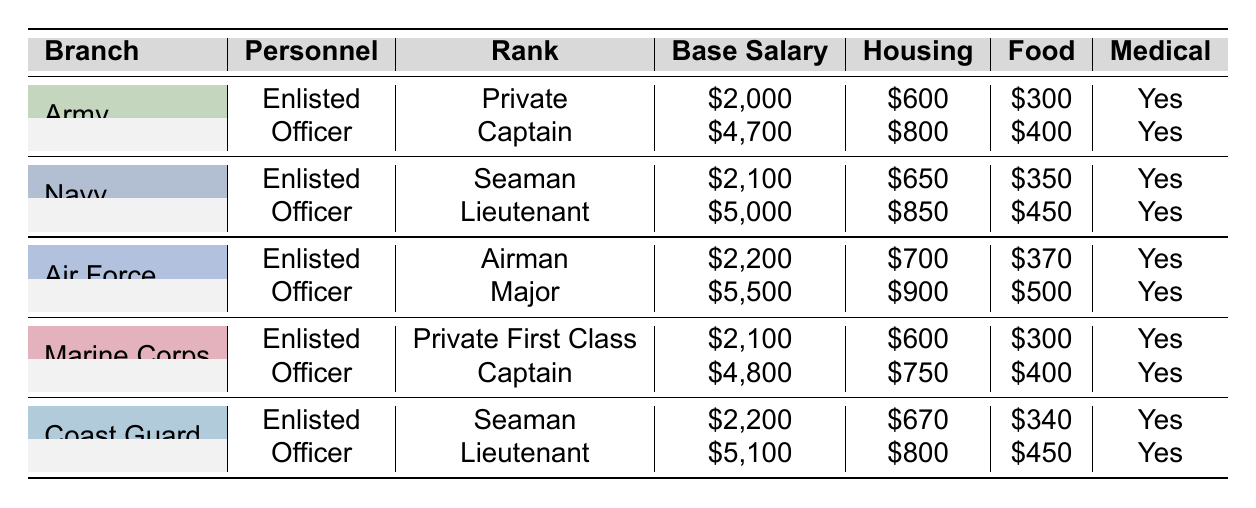What is the base salary for a Private in the Army? The table indicates that the base salary for a Private in the Army is listed under the Enlisted Personnel section. Looking at the row for the Army under Enlisted, the base salary is \$2,000.
Answer: 2000 Which branch has the highest base salary for officers? By examining the table, the base salaries for officers in each branch are as follows: Army: \$4,700, Navy: \$5,000, Air Force: \$5,500, Marine Corps: \$4,800, Coast Guard: \$5,100. The highest among these is \$5,500 for the Air Force.
Answer: Air Force What is the total monthly compensation for a Seaman in the Navy? To calculate the total compensation for a Seaman in the Navy, we add the base salary, housing allowance, and food allowance: \$2,100 (base) + \$650 (housing) + \$350 (food) = \$3,100.
Answer: 3100 Do all branches offer medical benefits? By checking the Medical Benefits column for each branch, we find that all entries show "Yes," indicating that every branch provides medical benefits to its personnel.
Answer: Yes Which enlisted personnel rank has the highest food allowance? Reviewing the Food Allowance column for enlisted ranks: Private (Army): \$300, Seaman (Navy): \$350, Airman (Air Force): \$370, Private First Class (Marine Corps): \$300, Seaman (Coast Guard): \$340. The highest food allowance is \$370 for the Airman in the Air Force.
Answer: Airman (Air Force) 